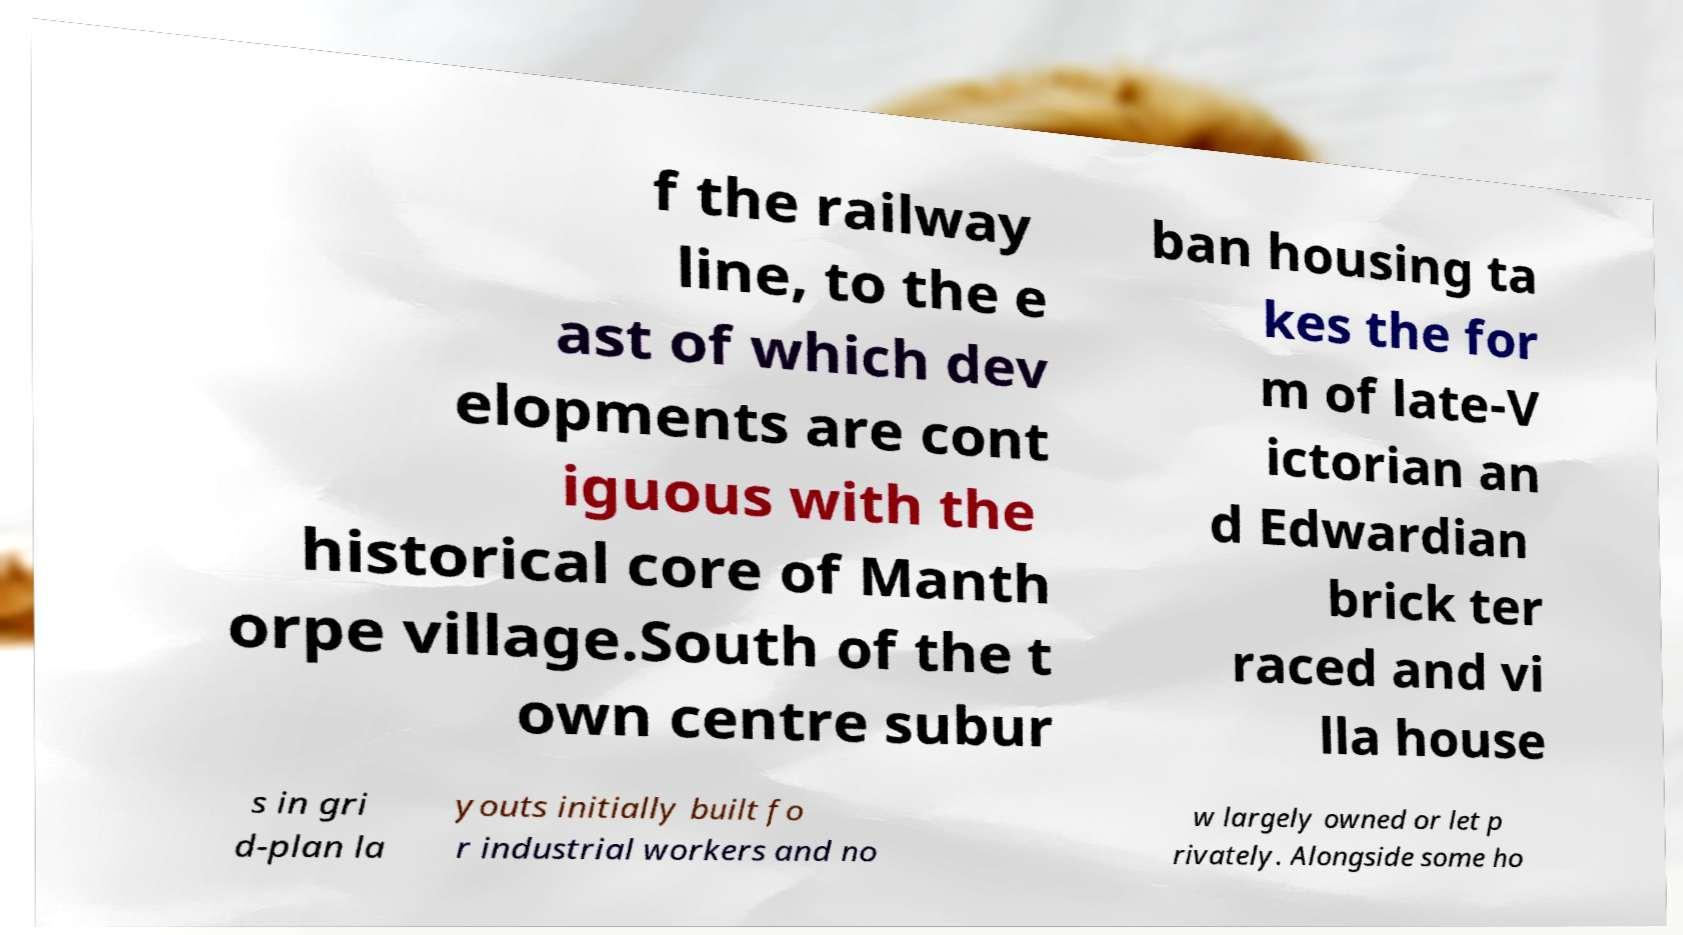Please read and relay the text visible in this image. What does it say? f the railway line, to the e ast of which dev elopments are cont iguous with the historical core of Manth orpe village.South of the t own centre subur ban housing ta kes the for m of late-V ictorian an d Edwardian brick ter raced and vi lla house s in gri d-plan la youts initially built fo r industrial workers and no w largely owned or let p rivately. Alongside some ho 